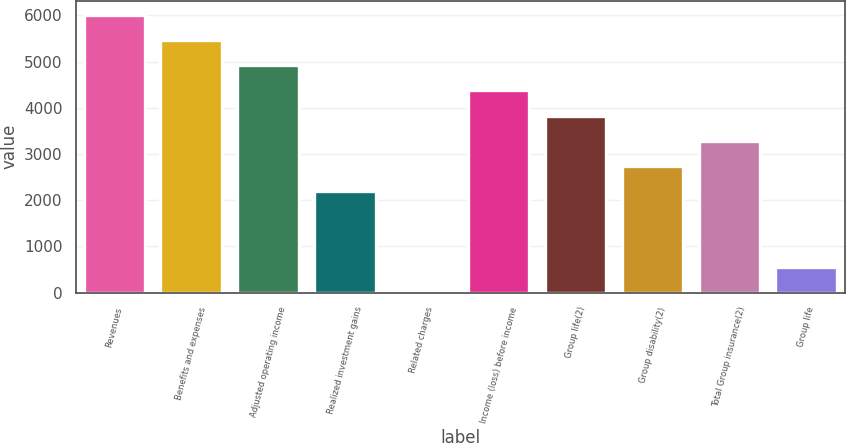Convert chart. <chart><loc_0><loc_0><loc_500><loc_500><bar_chart><fcel>Revenues<fcel>Benefits and expenses<fcel>Adjusted operating income<fcel>Realized investment gains<fcel>Related charges<fcel>Income (loss) before income<fcel>Group life(2)<fcel>Group disability(2)<fcel>Total Group insurance(2)<fcel>Group life<nl><fcel>6017.65<fcel>5471.02<fcel>4924.39<fcel>2191.24<fcel>4.72<fcel>4377.76<fcel>3831.13<fcel>2737.87<fcel>3284.5<fcel>551.35<nl></chart> 